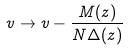Convert formula to latex. <formula><loc_0><loc_0><loc_500><loc_500>v \to v - \frac { M ( z ) } { N \Delta ( z ) }</formula> 